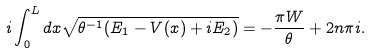Convert formula to latex. <formula><loc_0><loc_0><loc_500><loc_500>i \int _ { 0 } ^ { L } d x \sqrt { \theta ^ { - 1 } ( E _ { 1 } - V ( x ) + i E _ { 2 } ) } = - \frac { \pi W } { \theta } + 2 n \pi i .</formula> 